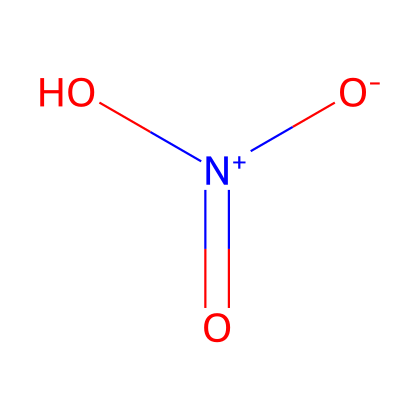What is the name of this chemical? The chemical represented by the given SMILES is nitrogen dioxide. The nitrogen atom is bonded to two oxygen atoms and a hydroxyl group, which is characteristic of nitrogen oxides.
Answer: nitrogen dioxide How many oxygen atoms are present? The structure contains three oxygen atoms: two are part of the nitrogen-dioxide structure, and one is bonded as a hydroxyl group. Count them to reach this conclusion.
Answer: three Is this compound a gas at room temperature? Nitrogen dioxide is known to be a gas at room temperature. Its physical properties have been studied, indicating its gaseous state under standard conditions.
Answer: yes Can this compound exhibit geometric isomerism? Geometric isomerism typically requires restricted rotation around a bond or a double bond, and nitrogen dioxide has no such structural characteristics, primarily being a simple linear molecule.
Answer: no What is the oxidation state of nitrogen in this molecule? The nitrogen atom in nitrogen dioxide has an oxidation state of +4. To calculate this, consider the total charge and the overall structure, observing how the nitrogen is bonded to the oxygens.
Answer: +4 Does this molecule have any polar bonds? Yes, the bonds between nitrogen and oxygen in this compound are polar because there is a significant electronegativity difference between nitrogen and oxygen. The unequal sharing of electrons leads to polar characteristics.
Answer: yes 